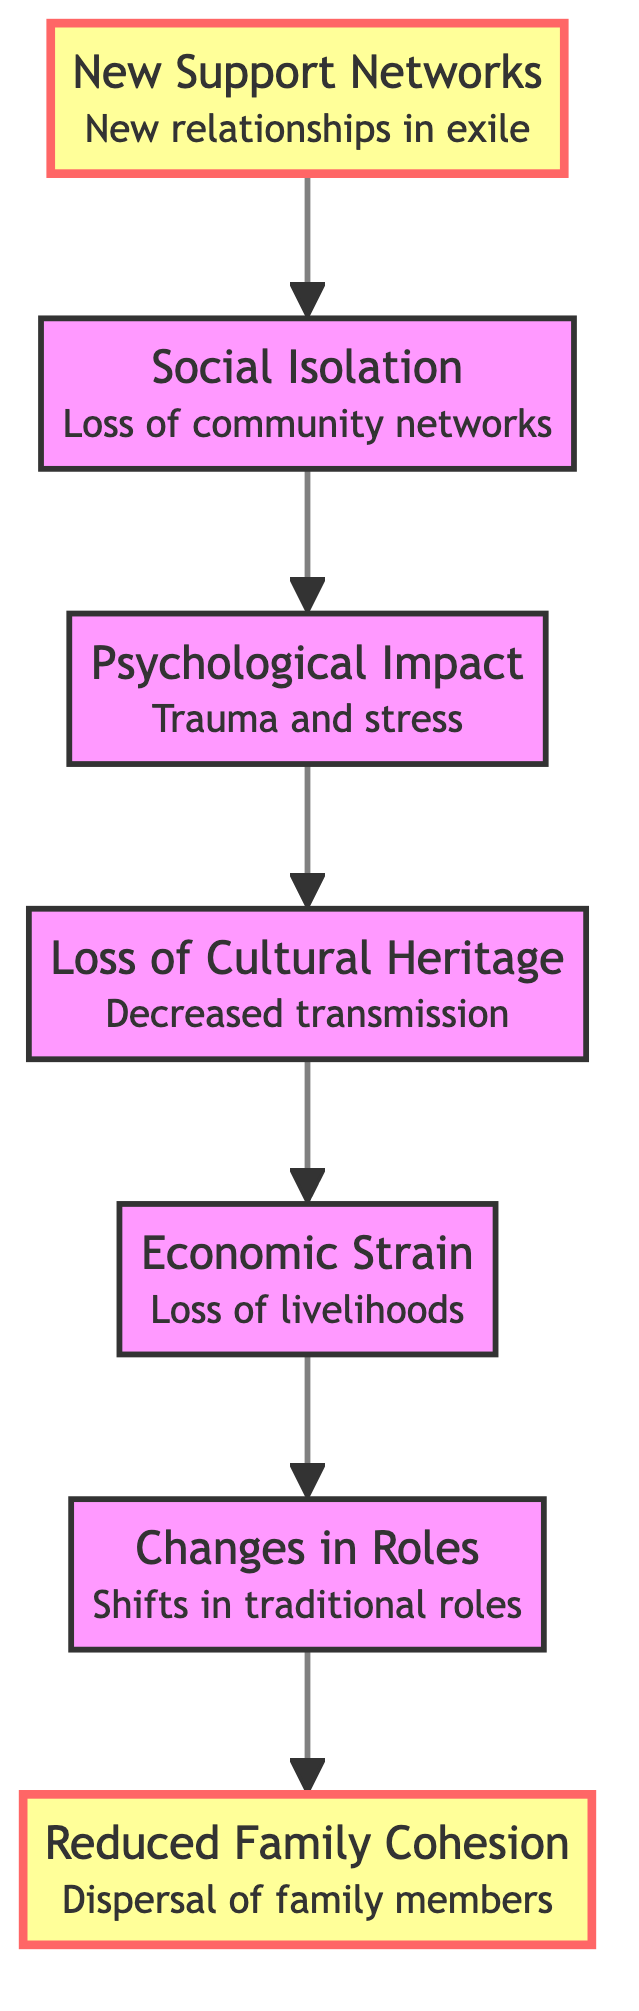What is the first element in the flowchart? The first element is labeled "Reduced Family Cohesion". It is the starting point of the flowchart at the bottom and is positioned at the lowest point in the flow.
Answer: Reduced Family Cohesion How many elements are in the flowchart? The flowchart contains seven elements. Each element represents a step in the flow of the impact of displacement on family structures.
Answer: 7 What is the last element in the flowchart? The last element in the flowchart is labeled "Formation of New Support Networks". It appears at the top of the diagram, indicating the final outcome after following the process through all previous elements.
Answer: Formation of New Support Networks What connects "Economic Strain" and "Psychological Impact"? There is a direct flow connection from "Economic Strain" leading into "Psychological Impact". This indicates a progression in the impact from economic issues to mental health effects.
Answer: Direct flow connection How does "Loss of Cultural Heritage" impact "Psychological Impact"? "Loss of Cultural Heritage" feeds into "Psychological Impact" in the flowchart. This implies that the loss of cultural traditions may contribute to psychological distress among family members.
Answer: Contributes to psychological distress What happens after "Social Isolation"? After "Social Isolation," the flowchart indicates a return to "Formation of New Support Networks". This suggests that even after experiencing isolation, communities may evolve by forming new supportive networks.
Answer: Formation of New Support Networks What is the significance of highlighted elements in the flowchart? The highlighted elements, "Reduced Family Cohesion" and "Formation of New Support Networks", signify key points within the context of the flowchart. They show the beginning and the resolution of family dynamics in the displacement narrative.
Answer: Key points: beginning and resolution 